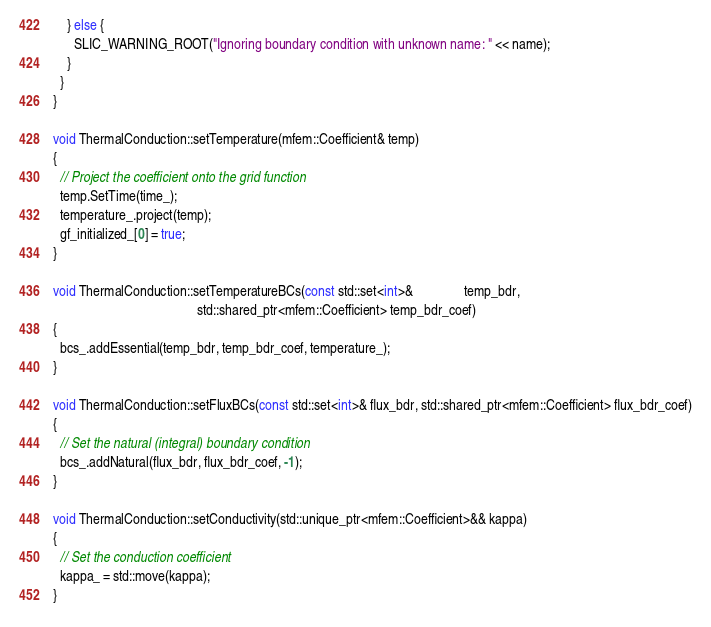<code> <loc_0><loc_0><loc_500><loc_500><_C++_>    } else {
      SLIC_WARNING_ROOT("Ignoring boundary condition with unknown name: " << name);
    }
  }
}

void ThermalConduction::setTemperature(mfem::Coefficient& temp)
{
  // Project the coefficient onto the grid function
  temp.SetTime(time_);
  temperature_.project(temp);
  gf_initialized_[0] = true;
}

void ThermalConduction::setTemperatureBCs(const std::set<int>&               temp_bdr,
                                          std::shared_ptr<mfem::Coefficient> temp_bdr_coef)
{
  bcs_.addEssential(temp_bdr, temp_bdr_coef, temperature_);
}

void ThermalConduction::setFluxBCs(const std::set<int>& flux_bdr, std::shared_ptr<mfem::Coefficient> flux_bdr_coef)
{
  // Set the natural (integral) boundary condition
  bcs_.addNatural(flux_bdr, flux_bdr_coef, -1);
}

void ThermalConduction::setConductivity(std::unique_ptr<mfem::Coefficient>&& kappa)
{
  // Set the conduction coefficient
  kappa_ = std::move(kappa);
}
</code> 